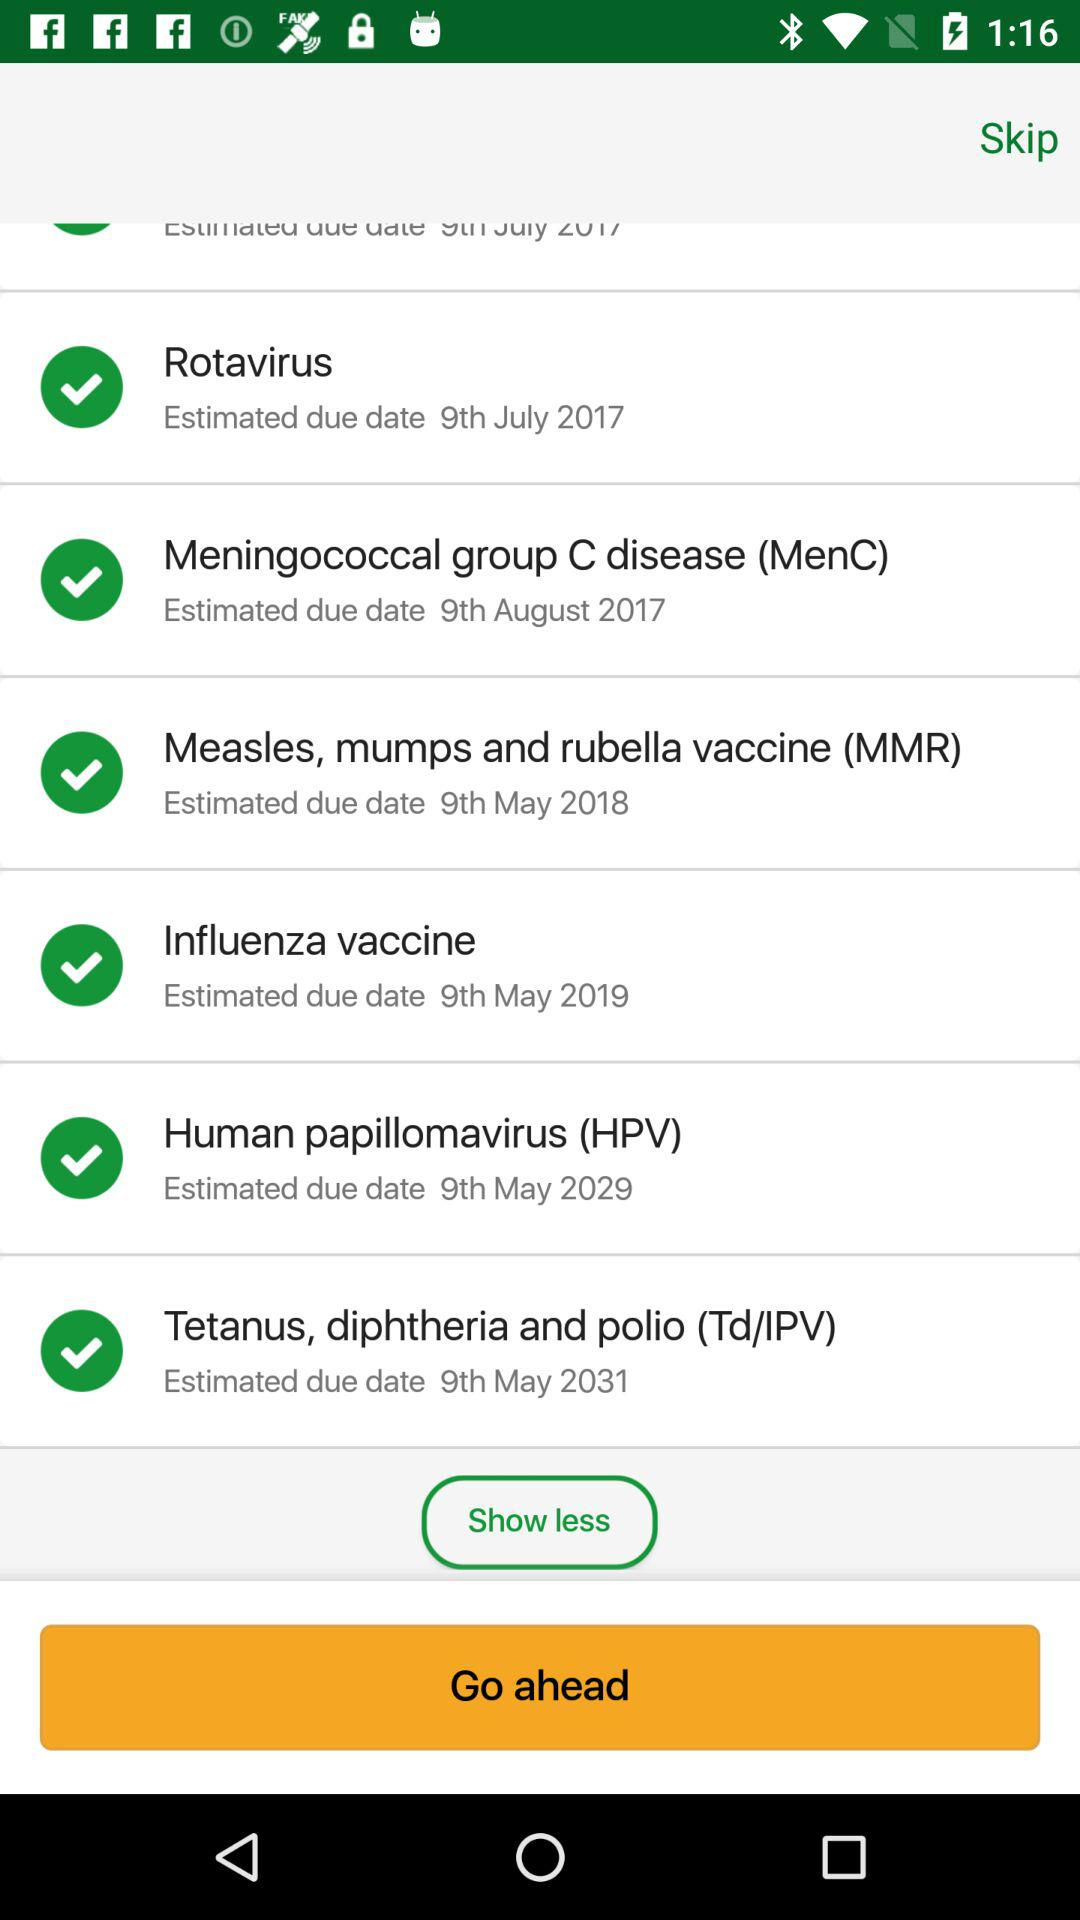What is the estimated due date of the influenza vaccine? The estimated due date of the influenza vaccine is May 9, 2019. 